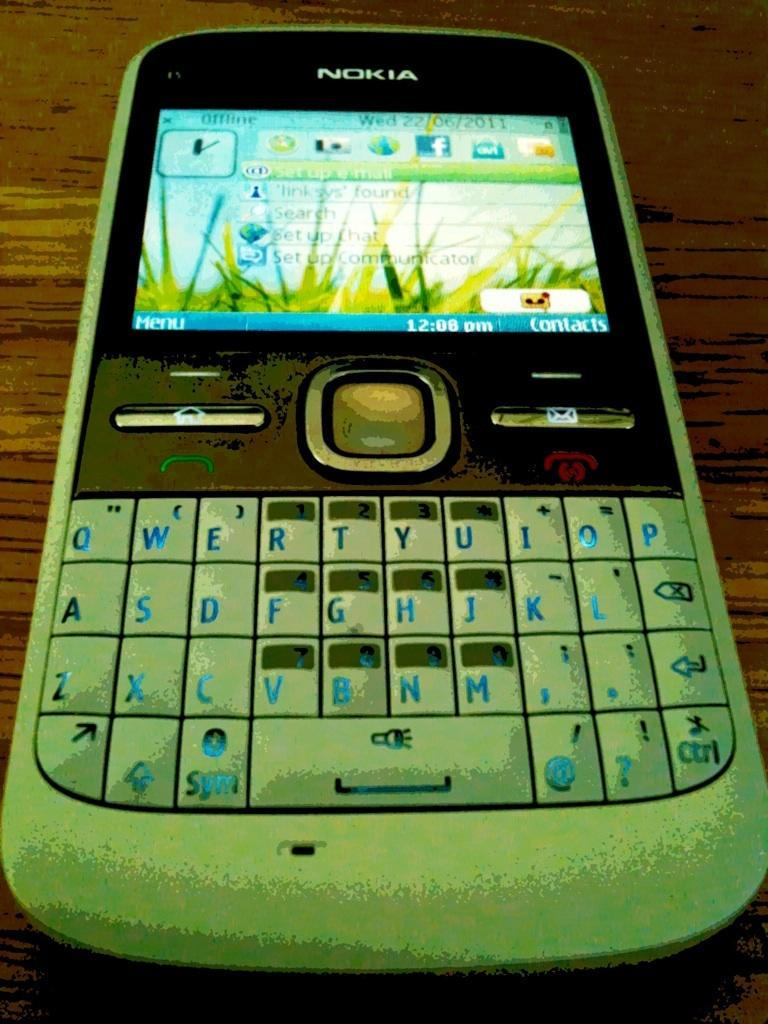What electronic device is visible in the image? There is a mobile phone in the image. Where is the mobile phone located? The mobile phone is on a table. Reasoning: Let's think step by step by step in order to produce the conversation. We start by identifying the main subject in the image, which is the mobile phone. Then, we expand the conversation to include the location of the mobile phone, which is on a table. Each question is designed to elicit a specific detail about the image that is known from the provided facts. Absurd Question/Answer: What type of cherry is being discovered by the mobile phone in the image? There is no cherry present in the image, and the mobile phone is not involved in any discovery process. 